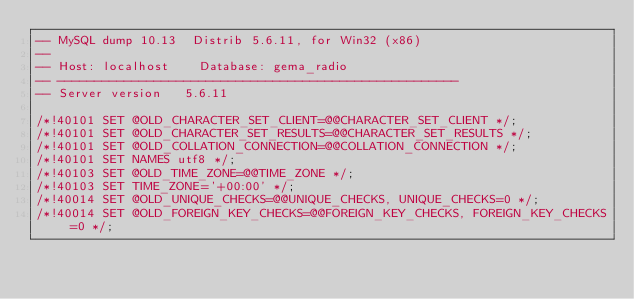<code> <loc_0><loc_0><loc_500><loc_500><_SQL_>-- MySQL dump 10.13  Distrib 5.6.11, for Win32 (x86)
--
-- Host: localhost    Database: gema_radio
-- ------------------------------------------------------
-- Server version	5.6.11

/*!40101 SET @OLD_CHARACTER_SET_CLIENT=@@CHARACTER_SET_CLIENT */;
/*!40101 SET @OLD_CHARACTER_SET_RESULTS=@@CHARACTER_SET_RESULTS */;
/*!40101 SET @OLD_COLLATION_CONNECTION=@@COLLATION_CONNECTION */;
/*!40101 SET NAMES utf8 */;
/*!40103 SET @OLD_TIME_ZONE=@@TIME_ZONE */;
/*!40103 SET TIME_ZONE='+00:00' */;
/*!40014 SET @OLD_UNIQUE_CHECKS=@@UNIQUE_CHECKS, UNIQUE_CHECKS=0 */;
/*!40014 SET @OLD_FOREIGN_KEY_CHECKS=@@FOREIGN_KEY_CHECKS, FOREIGN_KEY_CHECKS=0 */;</code> 